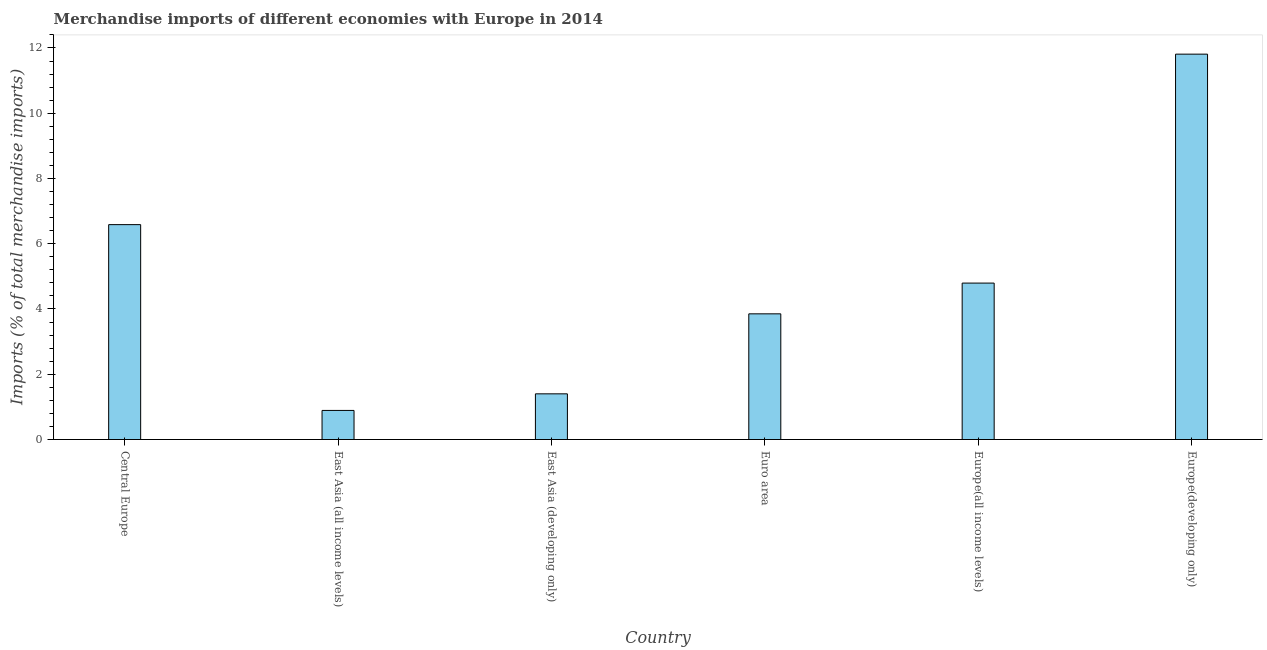Does the graph contain grids?
Your response must be concise. No. What is the title of the graph?
Your answer should be compact. Merchandise imports of different economies with Europe in 2014. What is the label or title of the X-axis?
Provide a succinct answer. Country. What is the label or title of the Y-axis?
Your answer should be very brief. Imports (% of total merchandise imports). What is the merchandise imports in Central Europe?
Your response must be concise. 6.59. Across all countries, what is the maximum merchandise imports?
Offer a very short reply. 11.81. Across all countries, what is the minimum merchandise imports?
Ensure brevity in your answer.  0.89. In which country was the merchandise imports maximum?
Your response must be concise. Europe(developing only). In which country was the merchandise imports minimum?
Your response must be concise. East Asia (all income levels). What is the sum of the merchandise imports?
Give a very brief answer. 29.33. What is the difference between the merchandise imports in Central Europe and East Asia (all income levels)?
Your answer should be compact. 5.69. What is the average merchandise imports per country?
Your answer should be very brief. 4.89. What is the median merchandise imports?
Ensure brevity in your answer.  4.32. What is the ratio of the merchandise imports in Central Europe to that in Euro area?
Your answer should be very brief. 1.71. Is the difference between the merchandise imports in Europe(all income levels) and Europe(developing only) greater than the difference between any two countries?
Your answer should be compact. No. What is the difference between the highest and the second highest merchandise imports?
Give a very brief answer. 5.22. What is the difference between the highest and the lowest merchandise imports?
Make the answer very short. 10.92. In how many countries, is the merchandise imports greater than the average merchandise imports taken over all countries?
Provide a short and direct response. 2. Are all the bars in the graph horizontal?
Make the answer very short. No. How many countries are there in the graph?
Your response must be concise. 6. What is the Imports (% of total merchandise imports) in Central Europe?
Give a very brief answer. 6.59. What is the Imports (% of total merchandise imports) in East Asia (all income levels)?
Your answer should be compact. 0.89. What is the Imports (% of total merchandise imports) in East Asia (developing only)?
Offer a terse response. 1.4. What is the Imports (% of total merchandise imports) of Euro area?
Keep it short and to the point. 3.85. What is the Imports (% of total merchandise imports) of Europe(all income levels)?
Give a very brief answer. 4.79. What is the Imports (% of total merchandise imports) in Europe(developing only)?
Offer a very short reply. 11.81. What is the difference between the Imports (% of total merchandise imports) in Central Europe and East Asia (all income levels)?
Your answer should be very brief. 5.69. What is the difference between the Imports (% of total merchandise imports) in Central Europe and East Asia (developing only)?
Offer a terse response. 5.19. What is the difference between the Imports (% of total merchandise imports) in Central Europe and Euro area?
Give a very brief answer. 2.73. What is the difference between the Imports (% of total merchandise imports) in Central Europe and Europe(all income levels)?
Make the answer very short. 1.79. What is the difference between the Imports (% of total merchandise imports) in Central Europe and Europe(developing only)?
Provide a succinct answer. -5.22. What is the difference between the Imports (% of total merchandise imports) in East Asia (all income levels) and East Asia (developing only)?
Offer a very short reply. -0.51. What is the difference between the Imports (% of total merchandise imports) in East Asia (all income levels) and Euro area?
Give a very brief answer. -2.96. What is the difference between the Imports (% of total merchandise imports) in East Asia (all income levels) and Europe(all income levels)?
Keep it short and to the point. -3.9. What is the difference between the Imports (% of total merchandise imports) in East Asia (all income levels) and Europe(developing only)?
Give a very brief answer. -10.92. What is the difference between the Imports (% of total merchandise imports) in East Asia (developing only) and Euro area?
Provide a succinct answer. -2.45. What is the difference between the Imports (% of total merchandise imports) in East Asia (developing only) and Europe(all income levels)?
Provide a succinct answer. -3.39. What is the difference between the Imports (% of total merchandise imports) in East Asia (developing only) and Europe(developing only)?
Your answer should be very brief. -10.41. What is the difference between the Imports (% of total merchandise imports) in Euro area and Europe(all income levels)?
Offer a very short reply. -0.94. What is the difference between the Imports (% of total merchandise imports) in Euro area and Europe(developing only)?
Make the answer very short. -7.96. What is the difference between the Imports (% of total merchandise imports) in Europe(all income levels) and Europe(developing only)?
Your answer should be very brief. -7.02. What is the ratio of the Imports (% of total merchandise imports) in Central Europe to that in East Asia (all income levels)?
Provide a short and direct response. 7.39. What is the ratio of the Imports (% of total merchandise imports) in Central Europe to that in East Asia (developing only)?
Give a very brief answer. 4.7. What is the ratio of the Imports (% of total merchandise imports) in Central Europe to that in Euro area?
Ensure brevity in your answer.  1.71. What is the ratio of the Imports (% of total merchandise imports) in Central Europe to that in Europe(all income levels)?
Ensure brevity in your answer.  1.37. What is the ratio of the Imports (% of total merchandise imports) in Central Europe to that in Europe(developing only)?
Your answer should be compact. 0.56. What is the ratio of the Imports (% of total merchandise imports) in East Asia (all income levels) to that in East Asia (developing only)?
Provide a short and direct response. 0.64. What is the ratio of the Imports (% of total merchandise imports) in East Asia (all income levels) to that in Euro area?
Offer a very short reply. 0.23. What is the ratio of the Imports (% of total merchandise imports) in East Asia (all income levels) to that in Europe(all income levels)?
Offer a terse response. 0.19. What is the ratio of the Imports (% of total merchandise imports) in East Asia (all income levels) to that in Europe(developing only)?
Your answer should be compact. 0.08. What is the ratio of the Imports (% of total merchandise imports) in East Asia (developing only) to that in Euro area?
Give a very brief answer. 0.36. What is the ratio of the Imports (% of total merchandise imports) in East Asia (developing only) to that in Europe(all income levels)?
Your response must be concise. 0.29. What is the ratio of the Imports (% of total merchandise imports) in East Asia (developing only) to that in Europe(developing only)?
Provide a succinct answer. 0.12. What is the ratio of the Imports (% of total merchandise imports) in Euro area to that in Europe(all income levels)?
Your answer should be very brief. 0.8. What is the ratio of the Imports (% of total merchandise imports) in Euro area to that in Europe(developing only)?
Your answer should be compact. 0.33. What is the ratio of the Imports (% of total merchandise imports) in Europe(all income levels) to that in Europe(developing only)?
Your answer should be very brief. 0.41. 